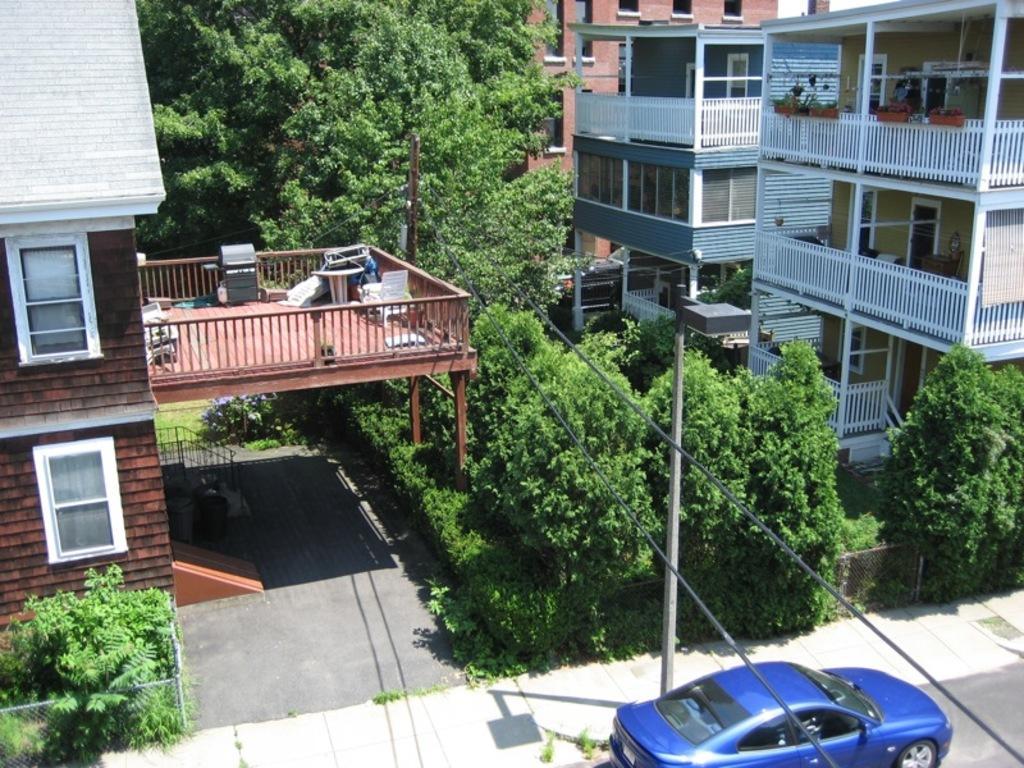How would you summarize this image in a sentence or two? In this image, we can see buildings, trees, railings, fences and there are vehicles on the road and we can see a pole along with wires. 